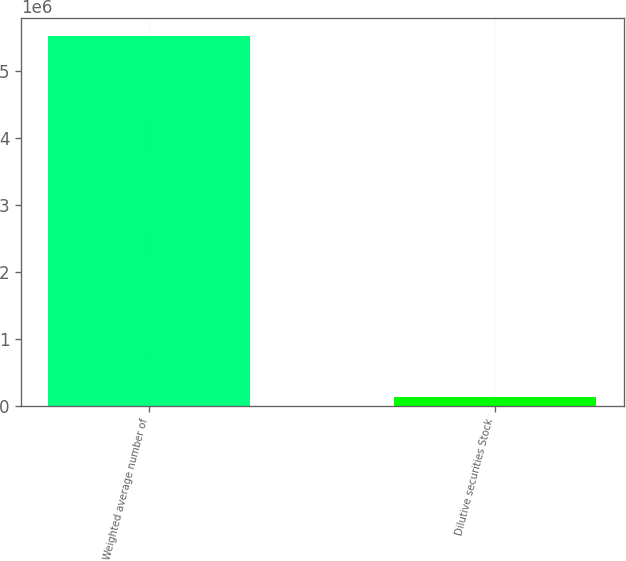Convert chart to OTSL. <chart><loc_0><loc_0><loc_500><loc_500><bar_chart><fcel>Weighted average number of<fcel>Dilutive securities Stock<nl><fcel>5.51216e+06<fcel>130471<nl></chart> 